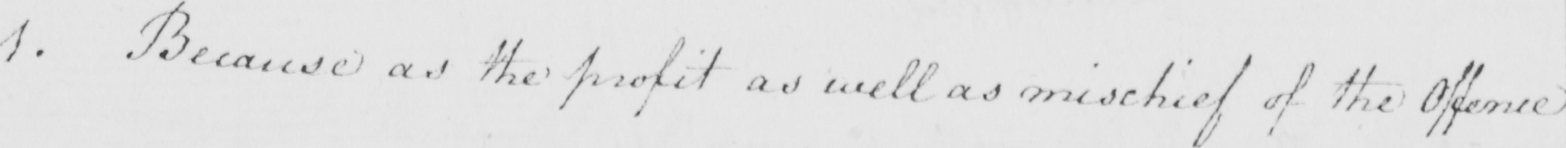What does this handwritten line say? 1 . Because as the profit as well as mischief of the Offence 